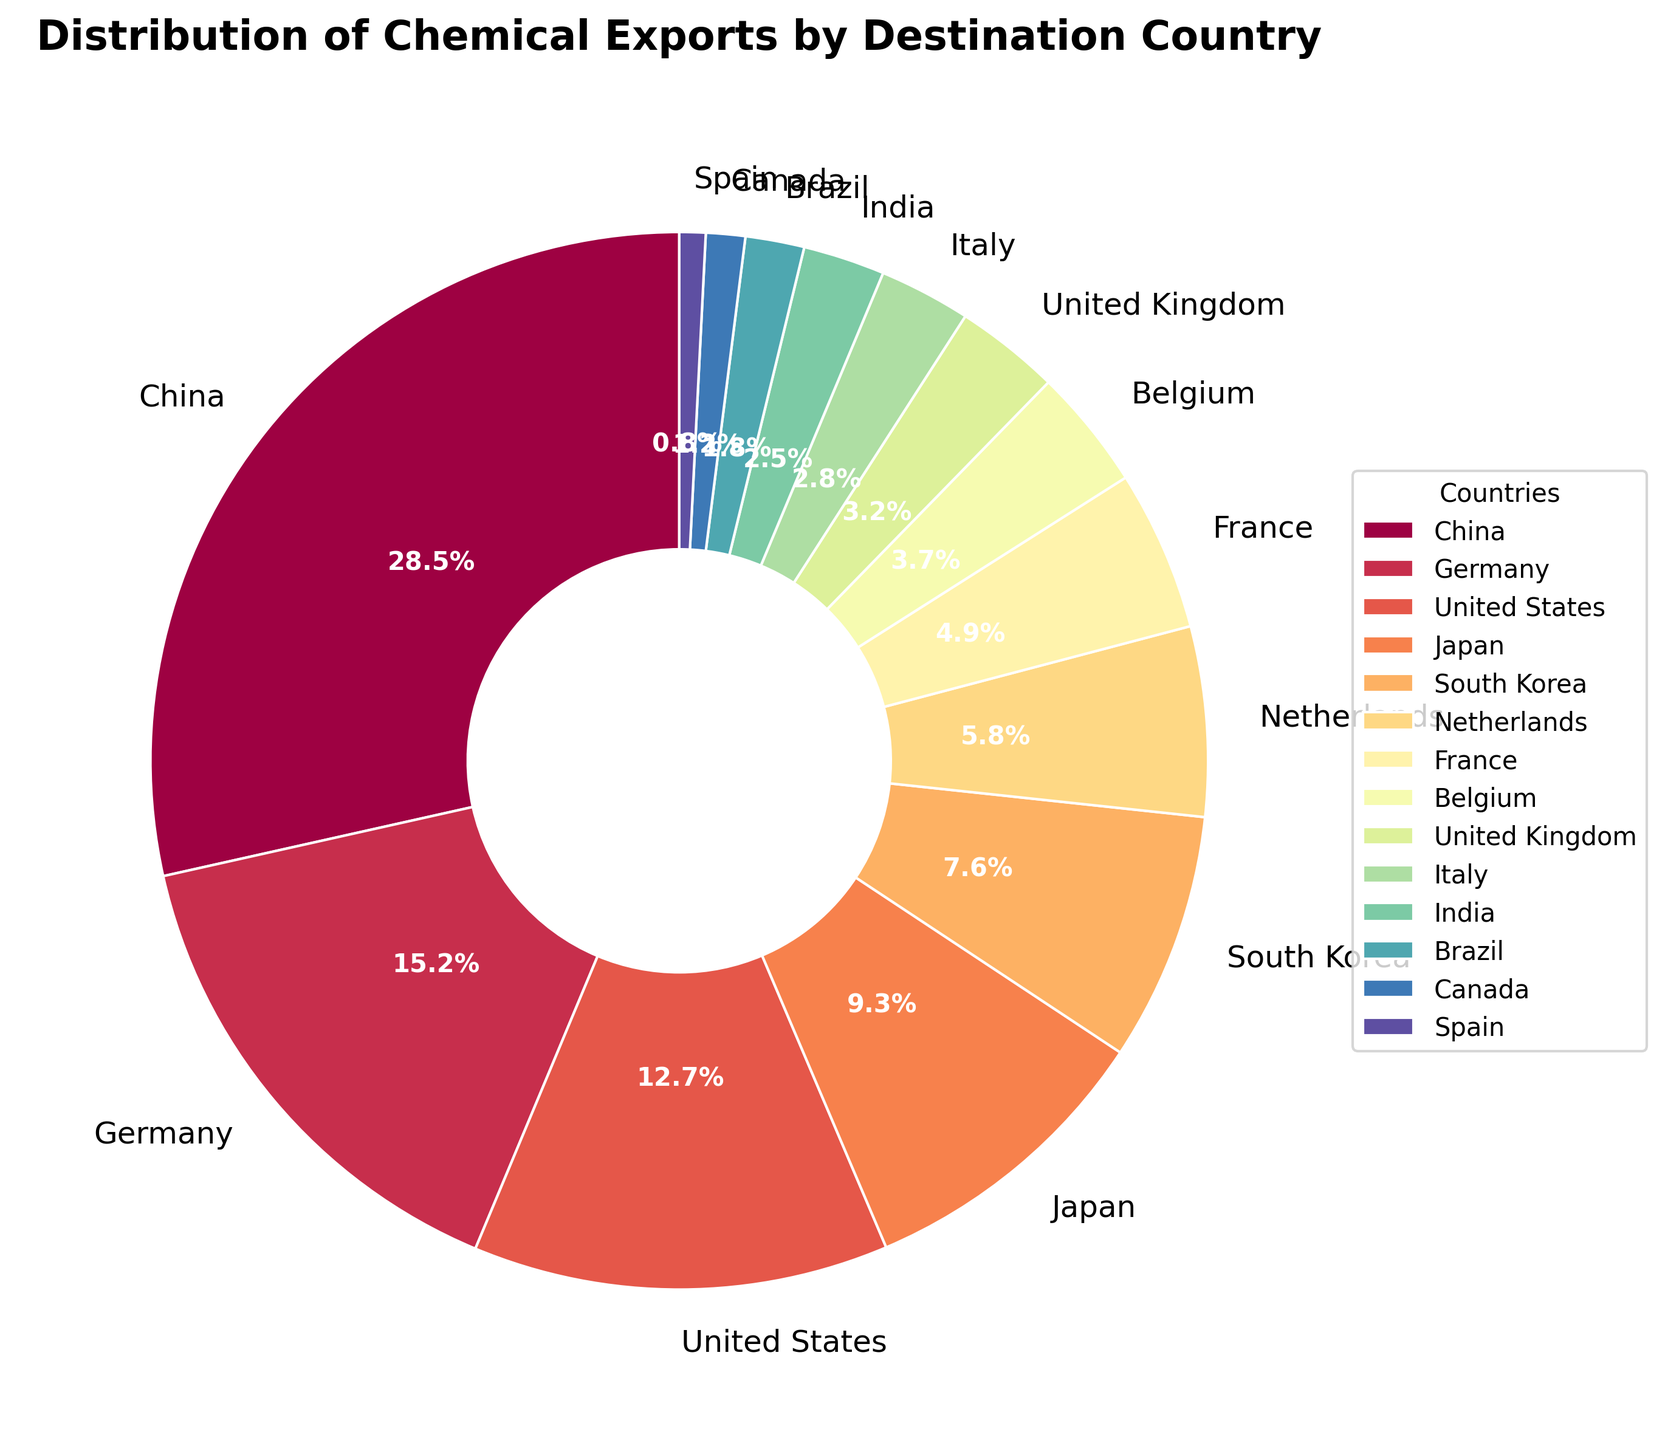What are the top three destination countries for chemical exports? The top three destination countries can be identified by the largest segments in the pie chart. Observing the segments, they are China, Germany, and the United States.
Answer: China, Germany, United States Which country receives the smallest percentage of chemical exports? The smallest segment in the pie chart represents the country with the smallest percentage. Observing the segments, the smallest one belongs to Spain.
Answer: Spain What is the combined percentage of chemical exports to China and Germany? From the pie chart, China has 28.5% and Germany has 15.2%. Summing these gives 28.5 + 15.2 = 43.7%.
Answer: 43.7% Which countries receive more than 10% of chemical exports? The segments representing more than 10% can be identified visually. From the pie chart, these countries are China (28.5%), Germany (15.2%), and the United States (12.7%).
Answer: China, Germany, United States Is the percentage of chemical exports to Japan higher or lower than that to the United States? Comparing the segments for Japan and the United States, Japan’s percentage (9.3%) is lower than that of the United States (12.7%).
Answer: Lower How does the percentage of chemical exports to Brazil compare to that to Canada? Observing the segments, Brazil has 1.8% while Canada has 1.2%. Therefore, Brazil’s percentage is higher.
Answer: Higher What is the total percentage of chemical exports to European countries in the list? Identifying European countries (Germany, Netherlands, France, Belgium, United Kingdom, Italy, Spain) and summing their percentages: Germany (15.2%), Netherlands (5.8%), France (4.9%), Belgium (3.7%), United Kingdom (3.2%), Italy (2.8%), Spain (0.8%). Summing these gives 15.2 + 5.8 + 4.9 + 3.7 + 3.2 + 2.8 + 0.8 = 36.4%.
Answer: 36.4% Which has a larger share: chemical exports to South Korea or the combined exports to Italy and India? South Korea has 7.6%. Combined exports to Italy and India are 2.8% + 2.5% = 5.3%. Therefore, South Korea has a larger share.
Answer: South Korea What is the difference in chemical export percentage between the Netherlands and France? The Netherlands has 5.8% and France has 4.9%. The difference is 5.8 - 4.9 = 0.9%.
Answer: 0.9% What is the average percentage of chemical exports for the five countries with the lowest shares? The five countries with the lowest shares are Spain (0.8%), Canada (1.2%), Brazil (1.8%), India (2.5%), and Italy (2.8%). The average is calculated as (0.8 + 1.2 + 1.8 + 2.5 + 2.8) / 5 = 9.1 / 5 = 1.82%.
Answer: 1.82% 